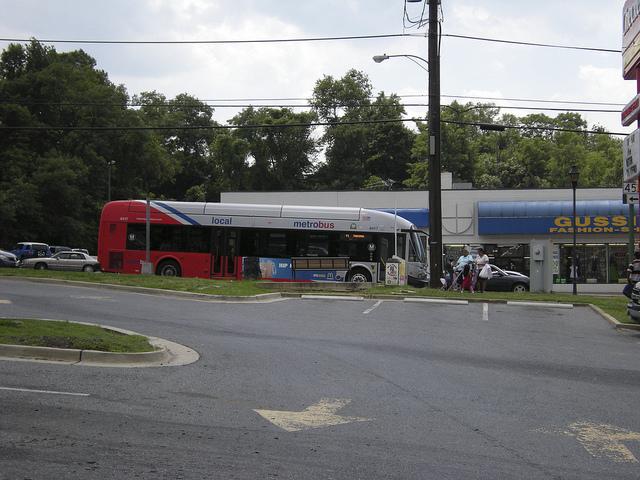Is this a new bus?
Write a very short answer. Yes. Is that a train?
Write a very short answer. No. Is this a food truck?
Write a very short answer. No. What is the name of the bus company?
Concise answer only. Metrobus. Is the bus behind a car?
Concise answer only. Yes. Is the bus moving?
Write a very short answer. No. Is this an agricultural community?
Concise answer only. No. Is the bus single or double story?
Answer briefly. Single. What color is the bus?
Keep it brief. White. Is this currently a busy street?
Be succinct. No. Which way is the arrow pointing?
Keep it brief. Down. Are any handicapped parking spaces visible in the photo?
Give a very brief answer. No. What are the yellow stripes in the road for?
Write a very short answer. Directions. What is the sign pointing at?
Give a very brief answer. Parking. Are there any emergency vehicles in the photo?
Quick response, please. No. 